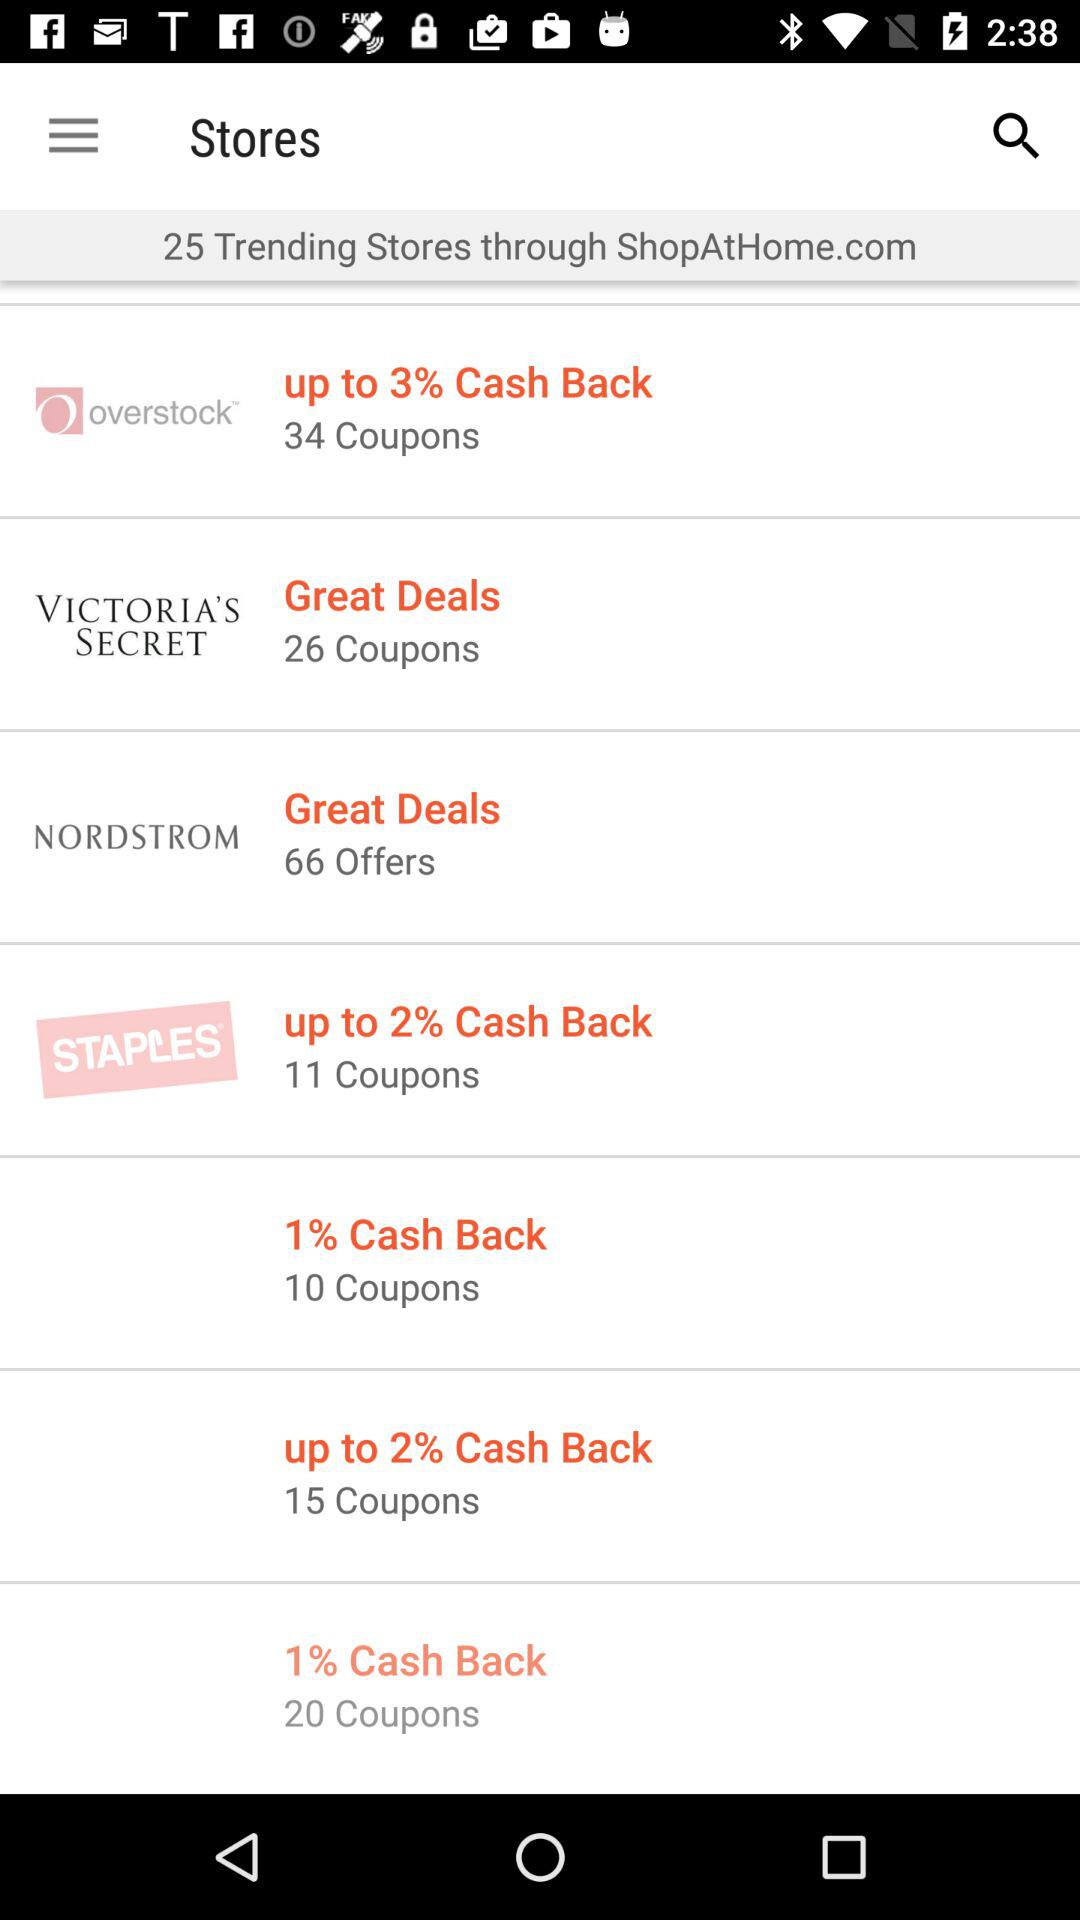What is cashback on "STAPLES"? The cashback is up to 2%. 